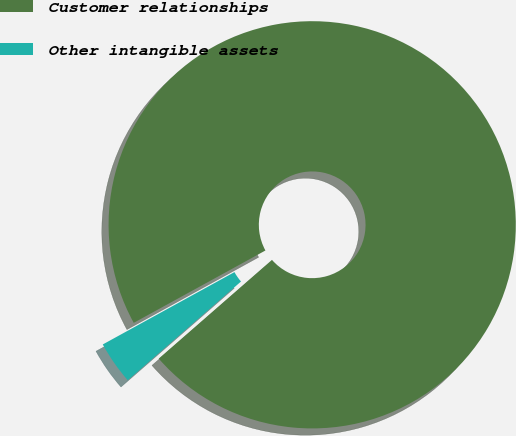Convert chart. <chart><loc_0><loc_0><loc_500><loc_500><pie_chart><fcel>Customer relationships<fcel>Other intangible assets<nl><fcel>96.58%<fcel>3.42%<nl></chart> 